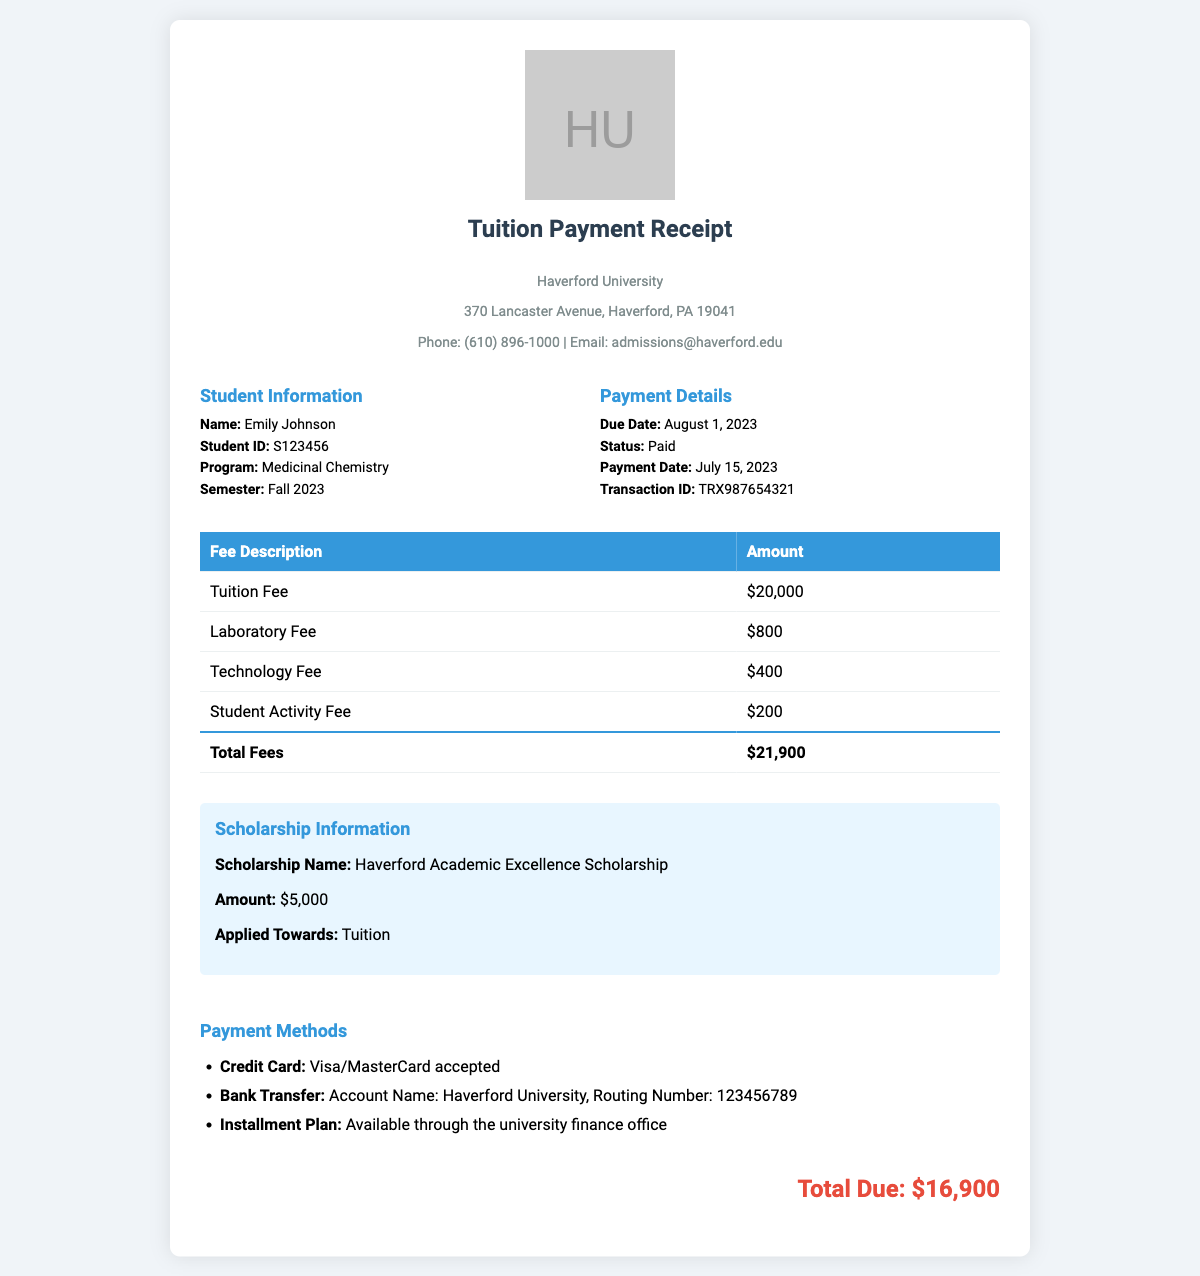What is the name of the student? The student's name is directly provided in the document under "Student Information."
Answer: Emily Johnson What is the total amount of fees before scholarship? The total fees listed in the document sum the individual fees, which is $21,900.
Answer: $21,900 What is the amount of the scholarship? The scholarship amount is explicitly stated in the "Scholarship Information" section of the document.
Answer: $5,000 What is the total due after applying the scholarship? The calculation for the total due is the total fees minus the scholarship, which is $21,900 - $5,000.
Answer: $16,900 When is the payment due date? The due date is provided in the "Payment Details" section of the document.
Answer: August 1, 2023 What program is the student enrolled in? The program of study for the student is specified in the document under "Student Information."
Answer: Medicinal Chemistry What is the payment method accepted for bank transfers? The accepted payment method for bank transfers is provided in the "Payment Methods" section of the document.
Answer: Haverford University What type of receipt is this document? The document clearly declares itself to be a tuition payment receipt.
Answer: Tuition Payment Receipt What is the transaction ID? The transaction ID is included in the payment details of the document.
Answer: TRX987654321 